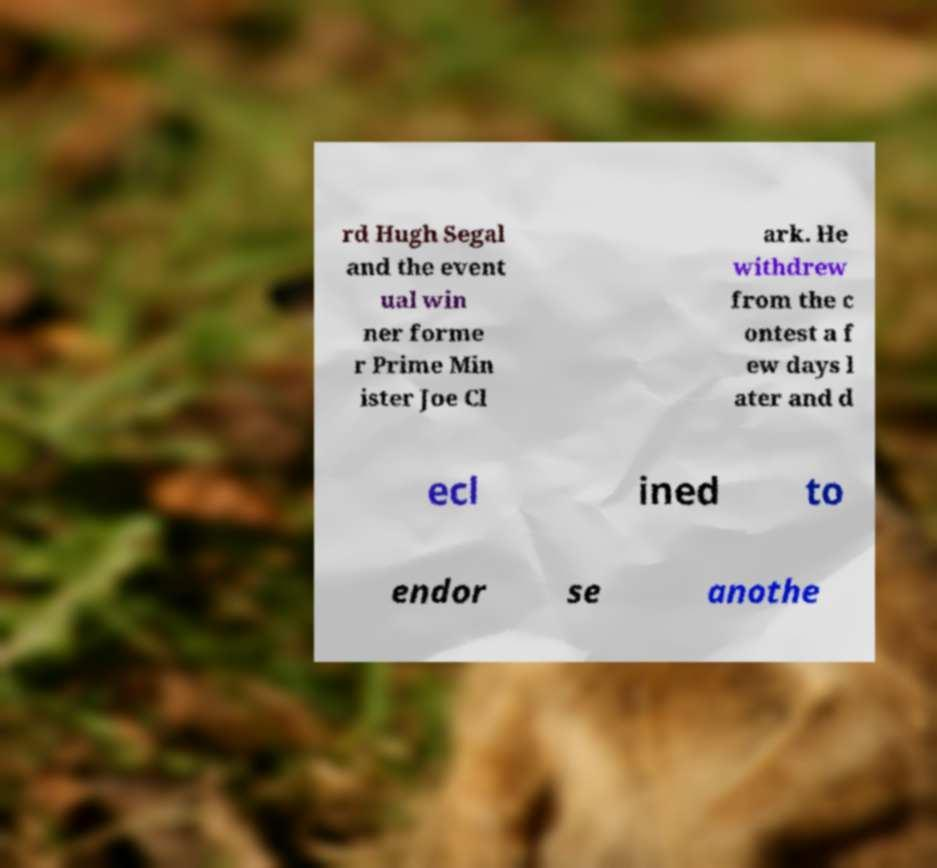Can you accurately transcribe the text from the provided image for me? rd Hugh Segal and the event ual win ner forme r Prime Min ister Joe Cl ark. He withdrew from the c ontest a f ew days l ater and d ecl ined to endor se anothe 